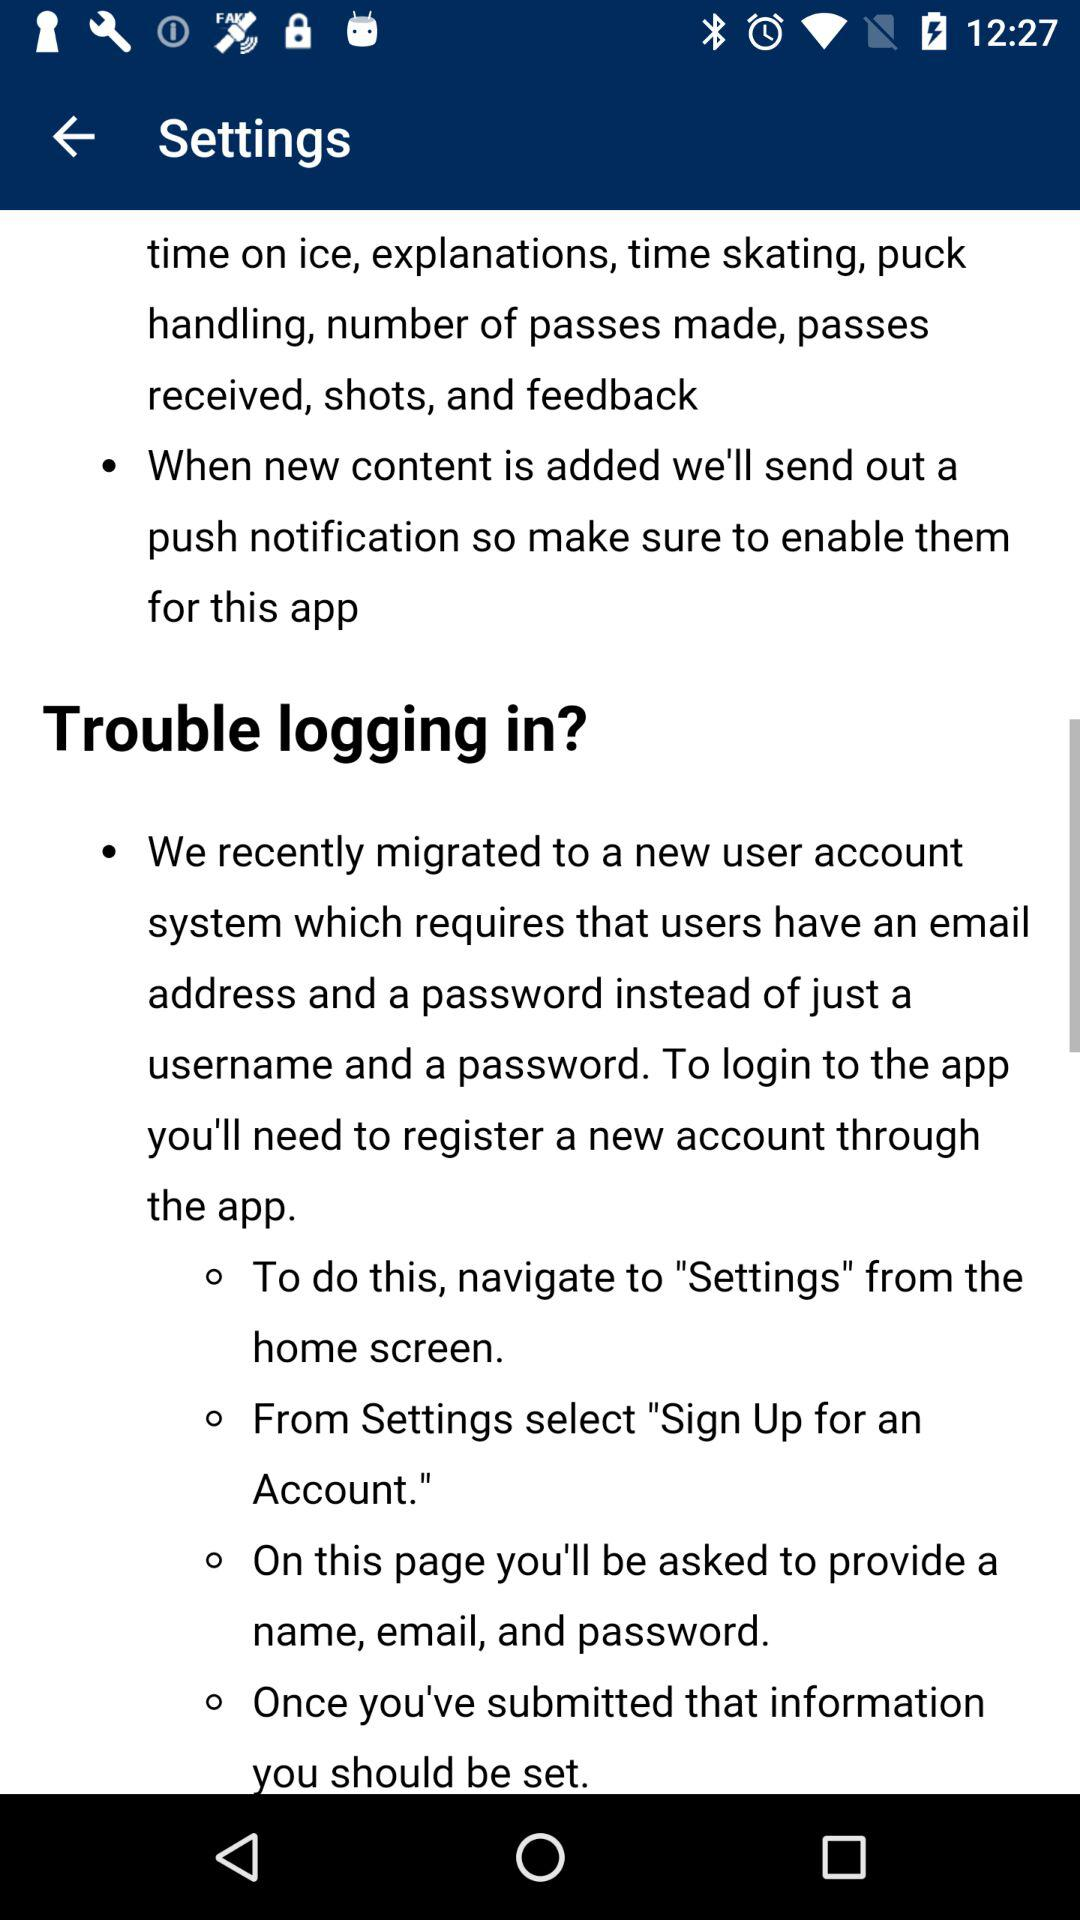How many steps are there to sign up for an account?
Answer the question using a single word or phrase. 4 